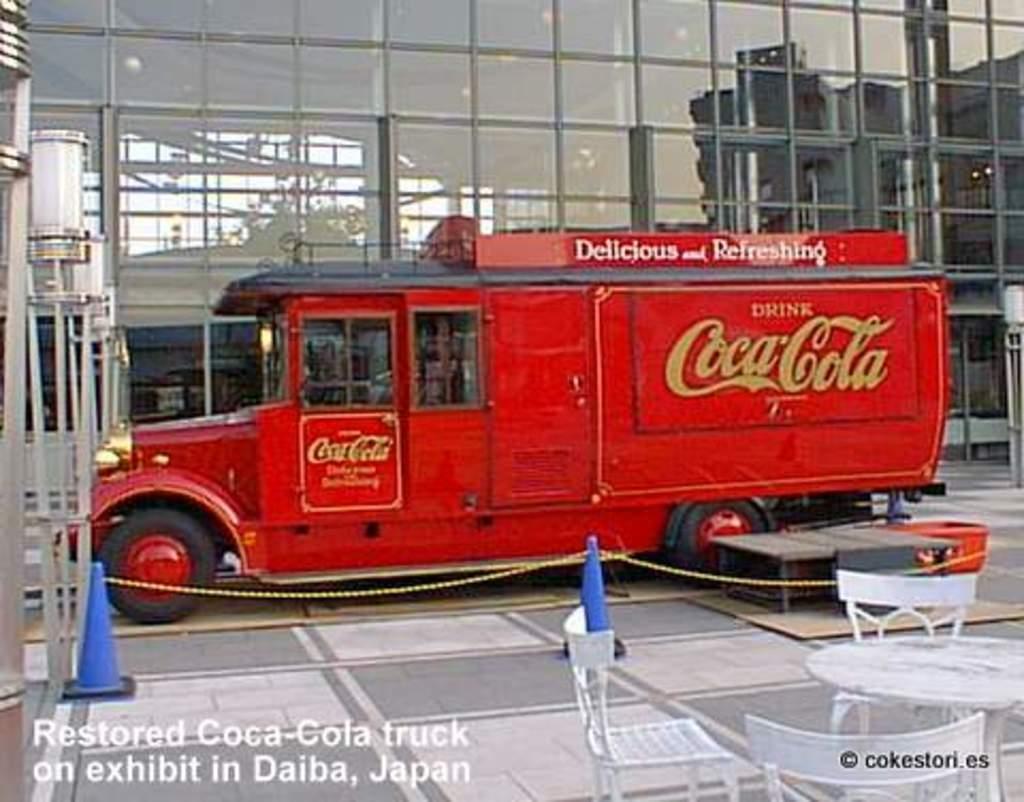In one or two sentences, can you explain what this image depicts? In this picture I can see a table and 3 chairs in front and in the middle of this picture I can see a truck, on which I can see few words written and I see 2 blue color cones and I see a rope. In the background I can see a building. On the bottom of this picture I can see the watermarks. 